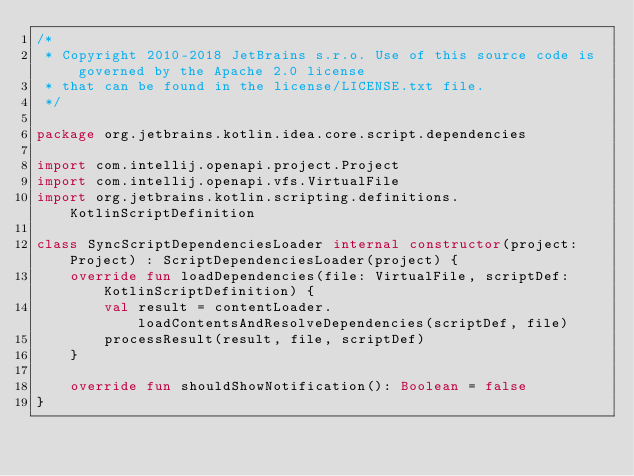Convert code to text. <code><loc_0><loc_0><loc_500><loc_500><_Kotlin_>/*
 * Copyright 2010-2018 JetBrains s.r.o. Use of this source code is governed by the Apache 2.0 license
 * that can be found in the license/LICENSE.txt file.
 */

package org.jetbrains.kotlin.idea.core.script.dependencies

import com.intellij.openapi.project.Project
import com.intellij.openapi.vfs.VirtualFile
import org.jetbrains.kotlin.scripting.definitions.KotlinScriptDefinition

class SyncScriptDependenciesLoader internal constructor(project: Project) : ScriptDependenciesLoader(project) {
    override fun loadDependencies(file: VirtualFile, scriptDef: KotlinScriptDefinition) {
        val result = contentLoader.loadContentsAndResolveDependencies(scriptDef, file)
        processResult(result, file, scriptDef)
    }

    override fun shouldShowNotification(): Boolean = false
}</code> 